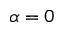Convert formula to latex. <formula><loc_0><loc_0><loc_500><loc_500>\alpha = 0</formula> 